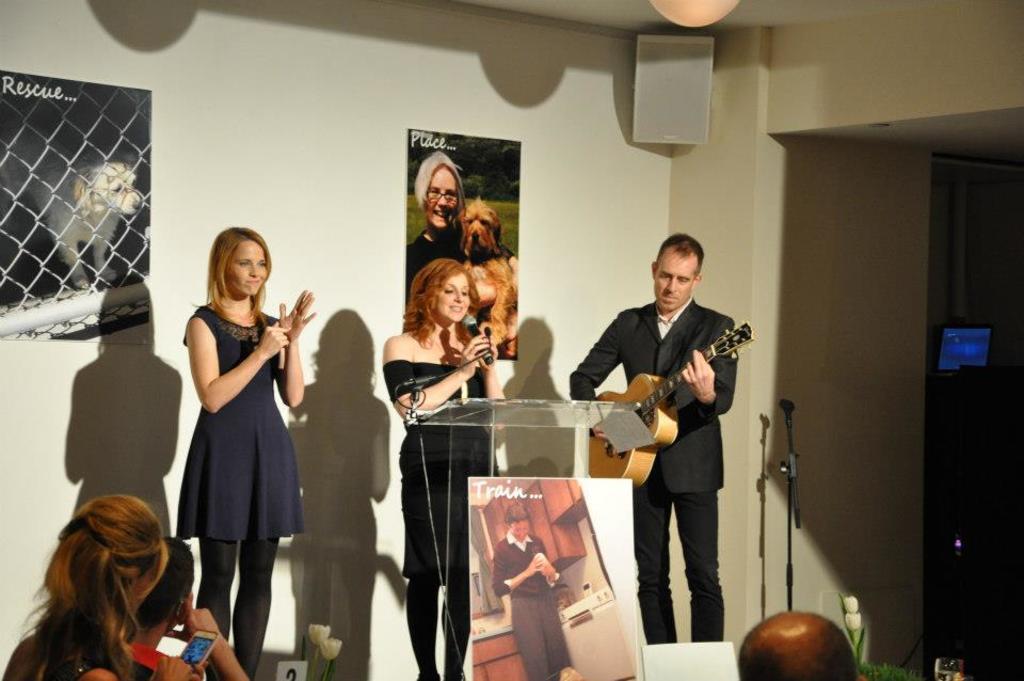Describe this image in one or two sentences. The image is taken in the room. There are three people standing. On the right there is a man standing and playing a guitar. On the left there is a lady standing. In the middle there is a lady who is holding a mic in her hand is singing. There is a podium before her. At the bottom there are people. In the background there is a wall and some posters which are pasted on the wall. 